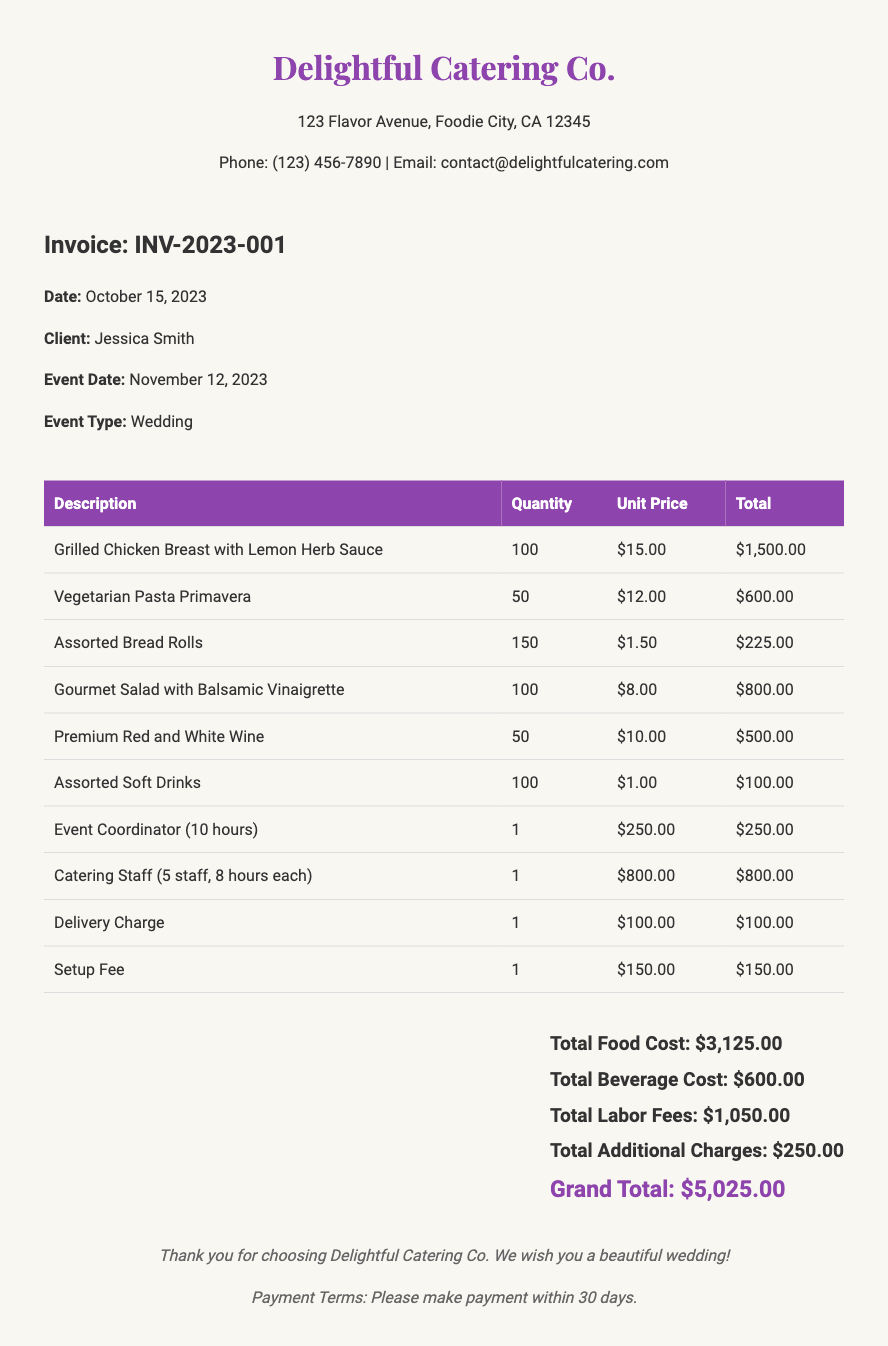What is the invoice number? The invoice number is specified in the document as INV-2023-001.
Answer: INV-2023-001 What is the date of the event? The event date is provided as November 12, 2023, which indicates when the catering service will take place.
Answer: November 12, 2023 What is the total beverage cost? The total beverage cost is clearly listed in the summary section as $600.00.
Answer: $600.00 How many servings of Grilled Chicken Breast were ordered? The quantity of Grilled Chicken Breast is shown in the itemized list as 100.
Answer: 100 What is the grand total amount due? The grand total is mentioned at the bottom of the summary as $5,025.00, which includes all costs.
Answer: $5,025.00 How many hours did the Event Coordinator work? The Event Coordinator's hours are detailed in the document as 10 hours.
Answer: 10 hours What is the setup fee charged? The setup fee is stated in the invoice as $150.00, making it a fixed charge for the setup service.
Answer: $150.00 Who is the client listed in the invoice? The client for this invoice is clearly indicated as Jessica Smith.
Answer: Jessica Smith What is the total labor fee? The total labor fees are summarized as $1,050.00, calculated from the service charges listed.
Answer: $1,050.00 